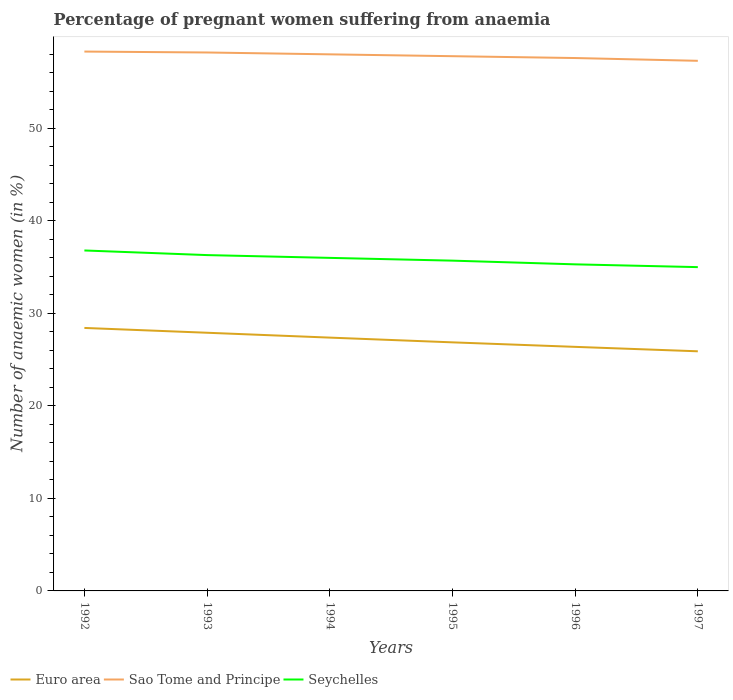How many different coloured lines are there?
Ensure brevity in your answer.  3. Across all years, what is the maximum number of anaemic women in Euro area?
Your response must be concise. 25.9. What is the total number of anaemic women in Sao Tome and Principe in the graph?
Provide a short and direct response. 0.6. What is the difference between the highest and the second highest number of anaemic women in Seychelles?
Ensure brevity in your answer.  1.8. How many years are there in the graph?
Provide a succinct answer. 6. What is the difference between two consecutive major ticks on the Y-axis?
Offer a very short reply. 10. Are the values on the major ticks of Y-axis written in scientific E-notation?
Give a very brief answer. No. How are the legend labels stacked?
Your answer should be very brief. Horizontal. What is the title of the graph?
Provide a succinct answer. Percentage of pregnant women suffering from anaemia. What is the label or title of the Y-axis?
Offer a terse response. Number of anaemic women (in %). What is the Number of anaemic women (in %) of Euro area in 1992?
Provide a short and direct response. 28.43. What is the Number of anaemic women (in %) of Sao Tome and Principe in 1992?
Offer a terse response. 58.3. What is the Number of anaemic women (in %) in Seychelles in 1992?
Make the answer very short. 36.8. What is the Number of anaemic women (in %) in Euro area in 1993?
Offer a very short reply. 27.91. What is the Number of anaemic women (in %) of Sao Tome and Principe in 1993?
Your response must be concise. 58.2. What is the Number of anaemic women (in %) of Seychelles in 1993?
Keep it short and to the point. 36.3. What is the Number of anaemic women (in %) of Euro area in 1994?
Your answer should be very brief. 27.38. What is the Number of anaemic women (in %) of Euro area in 1995?
Keep it short and to the point. 26.87. What is the Number of anaemic women (in %) in Sao Tome and Principe in 1995?
Your response must be concise. 57.8. What is the Number of anaemic women (in %) of Seychelles in 1995?
Your response must be concise. 35.7. What is the Number of anaemic women (in %) of Euro area in 1996?
Make the answer very short. 26.38. What is the Number of anaemic women (in %) in Sao Tome and Principe in 1996?
Your answer should be very brief. 57.6. What is the Number of anaemic women (in %) of Seychelles in 1996?
Offer a terse response. 35.3. What is the Number of anaemic women (in %) in Euro area in 1997?
Provide a succinct answer. 25.9. What is the Number of anaemic women (in %) of Sao Tome and Principe in 1997?
Offer a terse response. 57.3. Across all years, what is the maximum Number of anaemic women (in %) of Euro area?
Keep it short and to the point. 28.43. Across all years, what is the maximum Number of anaemic women (in %) of Sao Tome and Principe?
Give a very brief answer. 58.3. Across all years, what is the maximum Number of anaemic women (in %) in Seychelles?
Ensure brevity in your answer.  36.8. Across all years, what is the minimum Number of anaemic women (in %) in Euro area?
Offer a terse response. 25.9. Across all years, what is the minimum Number of anaemic women (in %) of Sao Tome and Principe?
Give a very brief answer. 57.3. Across all years, what is the minimum Number of anaemic women (in %) in Seychelles?
Make the answer very short. 35. What is the total Number of anaemic women (in %) in Euro area in the graph?
Offer a very short reply. 162.86. What is the total Number of anaemic women (in %) of Sao Tome and Principe in the graph?
Give a very brief answer. 347.2. What is the total Number of anaemic women (in %) of Seychelles in the graph?
Provide a succinct answer. 215.1. What is the difference between the Number of anaemic women (in %) in Euro area in 1992 and that in 1993?
Give a very brief answer. 0.52. What is the difference between the Number of anaemic women (in %) in Sao Tome and Principe in 1992 and that in 1993?
Offer a very short reply. 0.1. What is the difference between the Number of anaemic women (in %) in Euro area in 1992 and that in 1994?
Offer a terse response. 1.04. What is the difference between the Number of anaemic women (in %) of Sao Tome and Principe in 1992 and that in 1994?
Make the answer very short. 0.3. What is the difference between the Number of anaemic women (in %) of Euro area in 1992 and that in 1995?
Your answer should be very brief. 1.56. What is the difference between the Number of anaemic women (in %) of Euro area in 1992 and that in 1996?
Your answer should be compact. 2.04. What is the difference between the Number of anaemic women (in %) in Sao Tome and Principe in 1992 and that in 1996?
Keep it short and to the point. 0.7. What is the difference between the Number of anaemic women (in %) of Euro area in 1992 and that in 1997?
Offer a terse response. 2.52. What is the difference between the Number of anaemic women (in %) in Sao Tome and Principe in 1992 and that in 1997?
Provide a short and direct response. 1. What is the difference between the Number of anaemic women (in %) in Seychelles in 1992 and that in 1997?
Make the answer very short. 1.8. What is the difference between the Number of anaemic women (in %) in Euro area in 1993 and that in 1994?
Give a very brief answer. 0.53. What is the difference between the Number of anaemic women (in %) of Sao Tome and Principe in 1993 and that in 1994?
Ensure brevity in your answer.  0.2. What is the difference between the Number of anaemic women (in %) in Euro area in 1993 and that in 1995?
Offer a very short reply. 1.04. What is the difference between the Number of anaemic women (in %) of Sao Tome and Principe in 1993 and that in 1995?
Offer a terse response. 0.4. What is the difference between the Number of anaemic women (in %) in Seychelles in 1993 and that in 1995?
Provide a short and direct response. 0.6. What is the difference between the Number of anaemic women (in %) of Euro area in 1993 and that in 1996?
Give a very brief answer. 1.53. What is the difference between the Number of anaemic women (in %) of Sao Tome and Principe in 1993 and that in 1996?
Give a very brief answer. 0.6. What is the difference between the Number of anaemic women (in %) in Euro area in 1993 and that in 1997?
Your answer should be very brief. 2. What is the difference between the Number of anaemic women (in %) of Sao Tome and Principe in 1993 and that in 1997?
Provide a short and direct response. 0.9. What is the difference between the Number of anaemic women (in %) of Euro area in 1994 and that in 1995?
Provide a short and direct response. 0.51. What is the difference between the Number of anaemic women (in %) of Sao Tome and Principe in 1994 and that in 1995?
Your response must be concise. 0.2. What is the difference between the Number of anaemic women (in %) of Euro area in 1994 and that in 1997?
Provide a short and direct response. 1.48. What is the difference between the Number of anaemic women (in %) in Seychelles in 1994 and that in 1997?
Make the answer very short. 1. What is the difference between the Number of anaemic women (in %) of Euro area in 1995 and that in 1996?
Your answer should be very brief. 0.49. What is the difference between the Number of anaemic women (in %) of Sao Tome and Principe in 1995 and that in 1996?
Your response must be concise. 0.2. What is the difference between the Number of anaemic women (in %) in Euro area in 1995 and that in 1997?
Your answer should be very brief. 0.97. What is the difference between the Number of anaemic women (in %) of Sao Tome and Principe in 1995 and that in 1997?
Your answer should be very brief. 0.5. What is the difference between the Number of anaemic women (in %) of Seychelles in 1995 and that in 1997?
Offer a very short reply. 0.7. What is the difference between the Number of anaemic women (in %) of Euro area in 1996 and that in 1997?
Keep it short and to the point. 0.48. What is the difference between the Number of anaemic women (in %) in Seychelles in 1996 and that in 1997?
Provide a short and direct response. 0.3. What is the difference between the Number of anaemic women (in %) in Euro area in 1992 and the Number of anaemic women (in %) in Sao Tome and Principe in 1993?
Ensure brevity in your answer.  -29.77. What is the difference between the Number of anaemic women (in %) in Euro area in 1992 and the Number of anaemic women (in %) in Seychelles in 1993?
Provide a short and direct response. -7.87. What is the difference between the Number of anaemic women (in %) in Euro area in 1992 and the Number of anaemic women (in %) in Sao Tome and Principe in 1994?
Your answer should be compact. -29.57. What is the difference between the Number of anaemic women (in %) in Euro area in 1992 and the Number of anaemic women (in %) in Seychelles in 1994?
Keep it short and to the point. -7.57. What is the difference between the Number of anaemic women (in %) of Sao Tome and Principe in 1992 and the Number of anaemic women (in %) of Seychelles in 1994?
Offer a very short reply. 22.3. What is the difference between the Number of anaemic women (in %) in Euro area in 1992 and the Number of anaemic women (in %) in Sao Tome and Principe in 1995?
Make the answer very short. -29.37. What is the difference between the Number of anaemic women (in %) in Euro area in 1992 and the Number of anaemic women (in %) in Seychelles in 1995?
Make the answer very short. -7.27. What is the difference between the Number of anaemic women (in %) in Sao Tome and Principe in 1992 and the Number of anaemic women (in %) in Seychelles in 1995?
Your response must be concise. 22.6. What is the difference between the Number of anaemic women (in %) of Euro area in 1992 and the Number of anaemic women (in %) of Sao Tome and Principe in 1996?
Provide a succinct answer. -29.17. What is the difference between the Number of anaemic women (in %) in Euro area in 1992 and the Number of anaemic women (in %) in Seychelles in 1996?
Make the answer very short. -6.87. What is the difference between the Number of anaemic women (in %) of Euro area in 1992 and the Number of anaemic women (in %) of Sao Tome and Principe in 1997?
Your answer should be very brief. -28.87. What is the difference between the Number of anaemic women (in %) of Euro area in 1992 and the Number of anaemic women (in %) of Seychelles in 1997?
Give a very brief answer. -6.57. What is the difference between the Number of anaemic women (in %) of Sao Tome and Principe in 1992 and the Number of anaemic women (in %) of Seychelles in 1997?
Give a very brief answer. 23.3. What is the difference between the Number of anaemic women (in %) of Euro area in 1993 and the Number of anaemic women (in %) of Sao Tome and Principe in 1994?
Your answer should be compact. -30.09. What is the difference between the Number of anaemic women (in %) in Euro area in 1993 and the Number of anaemic women (in %) in Seychelles in 1994?
Ensure brevity in your answer.  -8.09. What is the difference between the Number of anaemic women (in %) of Sao Tome and Principe in 1993 and the Number of anaemic women (in %) of Seychelles in 1994?
Your answer should be very brief. 22.2. What is the difference between the Number of anaemic women (in %) in Euro area in 1993 and the Number of anaemic women (in %) in Sao Tome and Principe in 1995?
Ensure brevity in your answer.  -29.89. What is the difference between the Number of anaemic women (in %) of Euro area in 1993 and the Number of anaemic women (in %) of Seychelles in 1995?
Offer a terse response. -7.79. What is the difference between the Number of anaemic women (in %) of Euro area in 1993 and the Number of anaemic women (in %) of Sao Tome and Principe in 1996?
Keep it short and to the point. -29.69. What is the difference between the Number of anaemic women (in %) in Euro area in 1993 and the Number of anaemic women (in %) in Seychelles in 1996?
Offer a very short reply. -7.39. What is the difference between the Number of anaemic women (in %) in Sao Tome and Principe in 1993 and the Number of anaemic women (in %) in Seychelles in 1996?
Your answer should be compact. 22.9. What is the difference between the Number of anaemic women (in %) in Euro area in 1993 and the Number of anaemic women (in %) in Sao Tome and Principe in 1997?
Offer a terse response. -29.39. What is the difference between the Number of anaemic women (in %) of Euro area in 1993 and the Number of anaemic women (in %) of Seychelles in 1997?
Ensure brevity in your answer.  -7.09. What is the difference between the Number of anaemic women (in %) of Sao Tome and Principe in 1993 and the Number of anaemic women (in %) of Seychelles in 1997?
Provide a short and direct response. 23.2. What is the difference between the Number of anaemic women (in %) in Euro area in 1994 and the Number of anaemic women (in %) in Sao Tome and Principe in 1995?
Offer a terse response. -30.42. What is the difference between the Number of anaemic women (in %) in Euro area in 1994 and the Number of anaemic women (in %) in Seychelles in 1995?
Keep it short and to the point. -8.32. What is the difference between the Number of anaemic women (in %) in Sao Tome and Principe in 1994 and the Number of anaemic women (in %) in Seychelles in 1995?
Give a very brief answer. 22.3. What is the difference between the Number of anaemic women (in %) in Euro area in 1994 and the Number of anaemic women (in %) in Sao Tome and Principe in 1996?
Give a very brief answer. -30.22. What is the difference between the Number of anaemic women (in %) of Euro area in 1994 and the Number of anaemic women (in %) of Seychelles in 1996?
Your answer should be very brief. -7.92. What is the difference between the Number of anaemic women (in %) in Sao Tome and Principe in 1994 and the Number of anaemic women (in %) in Seychelles in 1996?
Provide a succinct answer. 22.7. What is the difference between the Number of anaemic women (in %) of Euro area in 1994 and the Number of anaemic women (in %) of Sao Tome and Principe in 1997?
Provide a short and direct response. -29.92. What is the difference between the Number of anaemic women (in %) in Euro area in 1994 and the Number of anaemic women (in %) in Seychelles in 1997?
Your response must be concise. -7.62. What is the difference between the Number of anaemic women (in %) in Sao Tome and Principe in 1994 and the Number of anaemic women (in %) in Seychelles in 1997?
Keep it short and to the point. 23. What is the difference between the Number of anaemic women (in %) of Euro area in 1995 and the Number of anaemic women (in %) of Sao Tome and Principe in 1996?
Offer a very short reply. -30.73. What is the difference between the Number of anaemic women (in %) in Euro area in 1995 and the Number of anaemic women (in %) in Seychelles in 1996?
Your answer should be very brief. -8.43. What is the difference between the Number of anaemic women (in %) of Euro area in 1995 and the Number of anaemic women (in %) of Sao Tome and Principe in 1997?
Offer a very short reply. -30.43. What is the difference between the Number of anaemic women (in %) in Euro area in 1995 and the Number of anaemic women (in %) in Seychelles in 1997?
Provide a succinct answer. -8.13. What is the difference between the Number of anaemic women (in %) in Sao Tome and Principe in 1995 and the Number of anaemic women (in %) in Seychelles in 1997?
Your response must be concise. 22.8. What is the difference between the Number of anaemic women (in %) in Euro area in 1996 and the Number of anaemic women (in %) in Sao Tome and Principe in 1997?
Make the answer very short. -30.92. What is the difference between the Number of anaemic women (in %) in Euro area in 1996 and the Number of anaemic women (in %) in Seychelles in 1997?
Your answer should be compact. -8.62. What is the difference between the Number of anaemic women (in %) in Sao Tome and Principe in 1996 and the Number of anaemic women (in %) in Seychelles in 1997?
Keep it short and to the point. 22.6. What is the average Number of anaemic women (in %) of Euro area per year?
Your answer should be very brief. 27.14. What is the average Number of anaemic women (in %) of Sao Tome and Principe per year?
Provide a short and direct response. 57.87. What is the average Number of anaemic women (in %) of Seychelles per year?
Ensure brevity in your answer.  35.85. In the year 1992, what is the difference between the Number of anaemic women (in %) in Euro area and Number of anaemic women (in %) in Sao Tome and Principe?
Your answer should be very brief. -29.87. In the year 1992, what is the difference between the Number of anaemic women (in %) in Euro area and Number of anaemic women (in %) in Seychelles?
Make the answer very short. -8.37. In the year 1992, what is the difference between the Number of anaemic women (in %) of Sao Tome and Principe and Number of anaemic women (in %) of Seychelles?
Ensure brevity in your answer.  21.5. In the year 1993, what is the difference between the Number of anaemic women (in %) of Euro area and Number of anaemic women (in %) of Sao Tome and Principe?
Your response must be concise. -30.29. In the year 1993, what is the difference between the Number of anaemic women (in %) in Euro area and Number of anaemic women (in %) in Seychelles?
Offer a very short reply. -8.39. In the year 1993, what is the difference between the Number of anaemic women (in %) in Sao Tome and Principe and Number of anaemic women (in %) in Seychelles?
Give a very brief answer. 21.9. In the year 1994, what is the difference between the Number of anaemic women (in %) of Euro area and Number of anaemic women (in %) of Sao Tome and Principe?
Provide a succinct answer. -30.62. In the year 1994, what is the difference between the Number of anaemic women (in %) of Euro area and Number of anaemic women (in %) of Seychelles?
Your answer should be very brief. -8.62. In the year 1994, what is the difference between the Number of anaemic women (in %) in Sao Tome and Principe and Number of anaemic women (in %) in Seychelles?
Offer a very short reply. 22. In the year 1995, what is the difference between the Number of anaemic women (in %) of Euro area and Number of anaemic women (in %) of Sao Tome and Principe?
Your answer should be very brief. -30.93. In the year 1995, what is the difference between the Number of anaemic women (in %) in Euro area and Number of anaemic women (in %) in Seychelles?
Your response must be concise. -8.83. In the year 1995, what is the difference between the Number of anaemic women (in %) of Sao Tome and Principe and Number of anaemic women (in %) of Seychelles?
Your response must be concise. 22.1. In the year 1996, what is the difference between the Number of anaemic women (in %) in Euro area and Number of anaemic women (in %) in Sao Tome and Principe?
Your answer should be very brief. -31.22. In the year 1996, what is the difference between the Number of anaemic women (in %) in Euro area and Number of anaemic women (in %) in Seychelles?
Make the answer very short. -8.92. In the year 1996, what is the difference between the Number of anaemic women (in %) of Sao Tome and Principe and Number of anaemic women (in %) of Seychelles?
Give a very brief answer. 22.3. In the year 1997, what is the difference between the Number of anaemic women (in %) of Euro area and Number of anaemic women (in %) of Sao Tome and Principe?
Offer a very short reply. -31.4. In the year 1997, what is the difference between the Number of anaemic women (in %) in Euro area and Number of anaemic women (in %) in Seychelles?
Offer a terse response. -9.1. In the year 1997, what is the difference between the Number of anaemic women (in %) of Sao Tome and Principe and Number of anaemic women (in %) of Seychelles?
Keep it short and to the point. 22.3. What is the ratio of the Number of anaemic women (in %) in Euro area in 1992 to that in 1993?
Make the answer very short. 1.02. What is the ratio of the Number of anaemic women (in %) in Sao Tome and Principe in 1992 to that in 1993?
Offer a very short reply. 1. What is the ratio of the Number of anaemic women (in %) of Seychelles in 1992 to that in 1993?
Give a very brief answer. 1.01. What is the ratio of the Number of anaemic women (in %) in Euro area in 1992 to that in 1994?
Your response must be concise. 1.04. What is the ratio of the Number of anaemic women (in %) in Seychelles in 1992 to that in 1994?
Your answer should be very brief. 1.02. What is the ratio of the Number of anaemic women (in %) in Euro area in 1992 to that in 1995?
Make the answer very short. 1.06. What is the ratio of the Number of anaemic women (in %) in Sao Tome and Principe in 1992 to that in 1995?
Your response must be concise. 1.01. What is the ratio of the Number of anaemic women (in %) in Seychelles in 1992 to that in 1995?
Provide a succinct answer. 1.03. What is the ratio of the Number of anaemic women (in %) in Euro area in 1992 to that in 1996?
Provide a succinct answer. 1.08. What is the ratio of the Number of anaemic women (in %) in Sao Tome and Principe in 1992 to that in 1996?
Offer a very short reply. 1.01. What is the ratio of the Number of anaemic women (in %) in Seychelles in 1992 to that in 1996?
Give a very brief answer. 1.04. What is the ratio of the Number of anaemic women (in %) in Euro area in 1992 to that in 1997?
Ensure brevity in your answer.  1.1. What is the ratio of the Number of anaemic women (in %) in Sao Tome and Principe in 1992 to that in 1997?
Provide a short and direct response. 1.02. What is the ratio of the Number of anaemic women (in %) of Seychelles in 1992 to that in 1997?
Your answer should be compact. 1.05. What is the ratio of the Number of anaemic women (in %) of Euro area in 1993 to that in 1994?
Offer a terse response. 1.02. What is the ratio of the Number of anaemic women (in %) in Seychelles in 1993 to that in 1994?
Your answer should be compact. 1.01. What is the ratio of the Number of anaemic women (in %) of Euro area in 1993 to that in 1995?
Your answer should be very brief. 1.04. What is the ratio of the Number of anaemic women (in %) of Seychelles in 1993 to that in 1995?
Make the answer very short. 1.02. What is the ratio of the Number of anaemic women (in %) in Euro area in 1993 to that in 1996?
Keep it short and to the point. 1.06. What is the ratio of the Number of anaemic women (in %) of Sao Tome and Principe in 1993 to that in 1996?
Your response must be concise. 1.01. What is the ratio of the Number of anaemic women (in %) of Seychelles in 1993 to that in 1996?
Provide a succinct answer. 1.03. What is the ratio of the Number of anaemic women (in %) in Euro area in 1993 to that in 1997?
Your answer should be compact. 1.08. What is the ratio of the Number of anaemic women (in %) of Sao Tome and Principe in 1993 to that in 1997?
Give a very brief answer. 1.02. What is the ratio of the Number of anaemic women (in %) in Seychelles in 1993 to that in 1997?
Ensure brevity in your answer.  1.04. What is the ratio of the Number of anaemic women (in %) in Euro area in 1994 to that in 1995?
Offer a very short reply. 1.02. What is the ratio of the Number of anaemic women (in %) of Sao Tome and Principe in 1994 to that in 1995?
Offer a terse response. 1. What is the ratio of the Number of anaemic women (in %) of Seychelles in 1994 to that in 1995?
Give a very brief answer. 1.01. What is the ratio of the Number of anaemic women (in %) in Euro area in 1994 to that in 1996?
Give a very brief answer. 1.04. What is the ratio of the Number of anaemic women (in %) in Sao Tome and Principe in 1994 to that in 1996?
Provide a succinct answer. 1.01. What is the ratio of the Number of anaemic women (in %) of Seychelles in 1994 to that in 1996?
Offer a very short reply. 1.02. What is the ratio of the Number of anaemic women (in %) of Euro area in 1994 to that in 1997?
Give a very brief answer. 1.06. What is the ratio of the Number of anaemic women (in %) of Sao Tome and Principe in 1994 to that in 1997?
Keep it short and to the point. 1.01. What is the ratio of the Number of anaemic women (in %) in Seychelles in 1994 to that in 1997?
Make the answer very short. 1.03. What is the ratio of the Number of anaemic women (in %) in Euro area in 1995 to that in 1996?
Provide a succinct answer. 1.02. What is the ratio of the Number of anaemic women (in %) in Sao Tome and Principe in 1995 to that in 1996?
Give a very brief answer. 1. What is the ratio of the Number of anaemic women (in %) in Seychelles in 1995 to that in 1996?
Offer a very short reply. 1.01. What is the ratio of the Number of anaemic women (in %) in Euro area in 1995 to that in 1997?
Your response must be concise. 1.04. What is the ratio of the Number of anaemic women (in %) of Sao Tome and Principe in 1995 to that in 1997?
Make the answer very short. 1.01. What is the ratio of the Number of anaemic women (in %) of Seychelles in 1995 to that in 1997?
Provide a short and direct response. 1.02. What is the ratio of the Number of anaemic women (in %) in Euro area in 1996 to that in 1997?
Your answer should be compact. 1.02. What is the ratio of the Number of anaemic women (in %) in Seychelles in 1996 to that in 1997?
Your answer should be very brief. 1.01. What is the difference between the highest and the second highest Number of anaemic women (in %) of Euro area?
Offer a very short reply. 0.52. What is the difference between the highest and the second highest Number of anaemic women (in %) in Sao Tome and Principe?
Your answer should be very brief. 0.1. What is the difference between the highest and the second highest Number of anaemic women (in %) in Seychelles?
Offer a terse response. 0.5. What is the difference between the highest and the lowest Number of anaemic women (in %) in Euro area?
Provide a succinct answer. 2.52. 